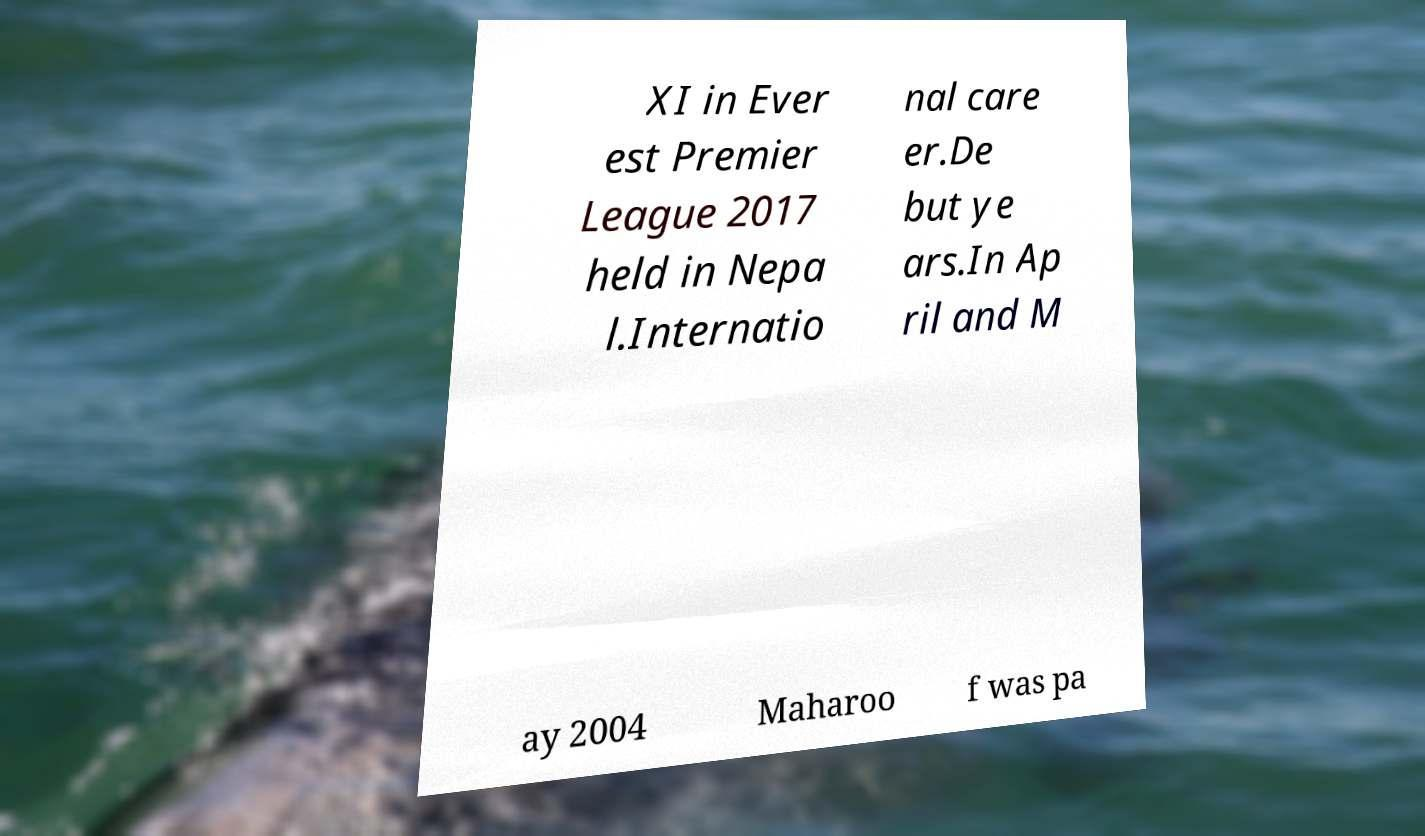Please read and relay the text visible in this image. What does it say? XI in Ever est Premier League 2017 held in Nepa l.Internatio nal care er.De but ye ars.In Ap ril and M ay 2004 Maharoo f was pa 